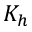Convert formula to latex. <formula><loc_0><loc_0><loc_500><loc_500>K _ { h }</formula> 